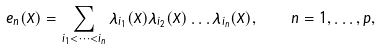Convert formula to latex. <formula><loc_0><loc_0><loc_500><loc_500>e _ { n } ( X ) = \sum _ { i _ { 1 } < \dots < i _ { n } } \lambda _ { i _ { 1 } } ( X ) \lambda _ { i _ { 2 } } ( X ) \dots \lambda _ { i _ { n } } ( X ) \/ , \quad n = 1 , \dots , p ,</formula> 